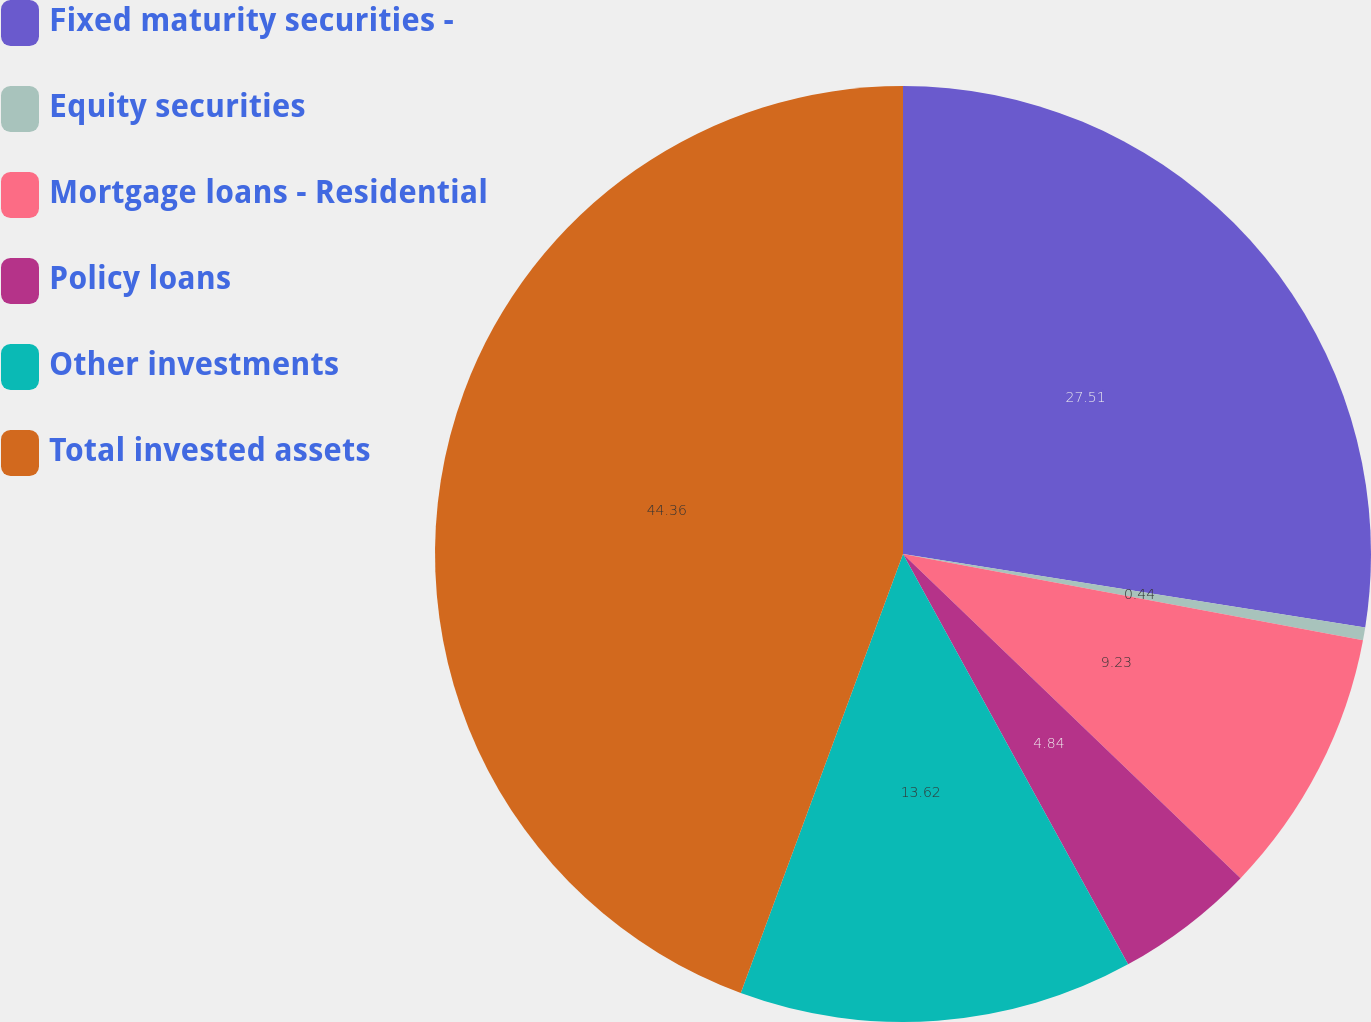<chart> <loc_0><loc_0><loc_500><loc_500><pie_chart><fcel>Fixed maturity securities -<fcel>Equity securities<fcel>Mortgage loans - Residential<fcel>Policy loans<fcel>Other investments<fcel>Total invested assets<nl><fcel>27.51%<fcel>0.44%<fcel>9.23%<fcel>4.84%<fcel>13.62%<fcel>44.37%<nl></chart> 